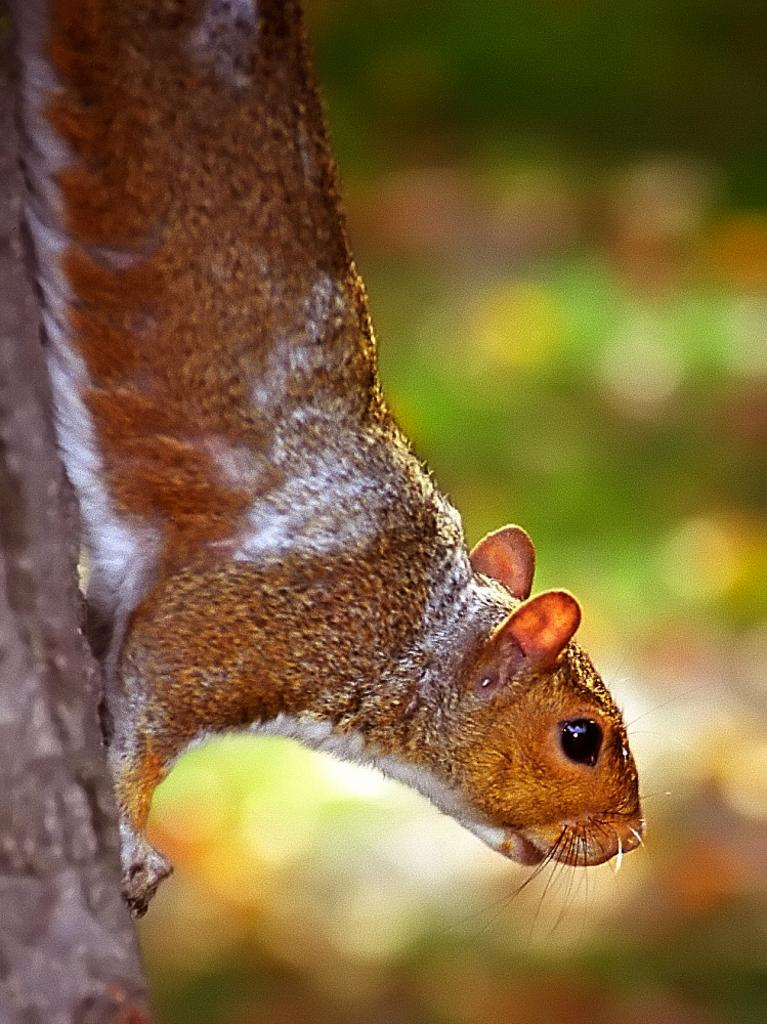What animal is present in the image? There is a rat in the image. Where is the rat located? The rat is on a tree trunk. What type of dress is the rat wearing in the image? There is no dress present in the image, as the rat is an animal and does not wear clothing. 